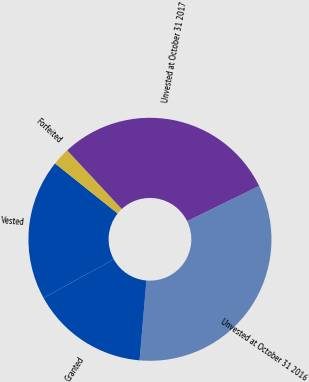Convert chart to OTSL. <chart><loc_0><loc_0><loc_500><loc_500><pie_chart><fcel>Unvested at October 31 2016<fcel>Granted<fcel>Vested<fcel>Forfeited<fcel>Unvested at October 31 2017<nl><fcel>33.59%<fcel>15.62%<fcel>18.75%<fcel>2.34%<fcel>29.69%<nl></chart> 